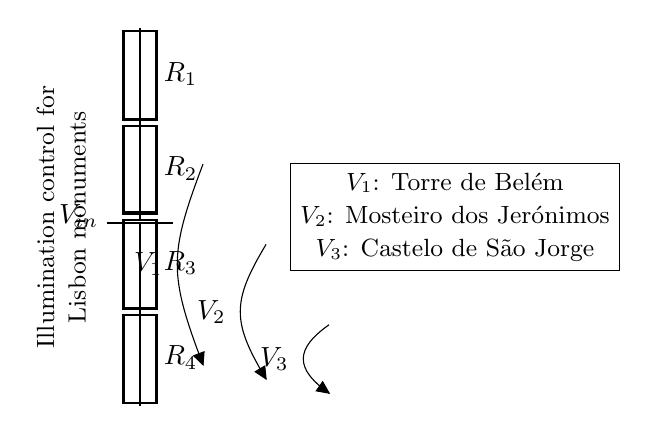What is the value of the input voltage? The input voltage is labeled as V_in at the top of the circuit, indicating the source of electrical power for the voltage divider.
Answer: V_in What components are present in this circuit? The circuit consists of a battery and four resistors labeled R_1, R_2, R_3, and R_4, which are connected in series.
Answer: Battery and four resistors How many output voltages are there in total? The circuit shows three output voltages labeled as V_1, V_2, and V_3, corresponding to different points in the voltage divider.
Answer: Three Which monument is associated with the voltage V_1? The voltage V_1 is specified in the circuit diagram to correspond to Torre de Belém, a historic monument in Lisbon.
Answer: Torre de Belém How do the voltage outputs relate to the resistors? The voltage outputs V_1, V_2, and V_3 are derived from the voltage division across the resistors R_1, R_2, and R_3, following the voltage divider rule. The relationship is determined by the values of the resistors and their series configuration.
Answer: By voltage division What is the role of the resistors in this circuit? The resistors in the circuit serve to divide the input voltage into several lower voltages, allowing for controlled illumination of the monuments based on the set voltage levels at the outputs.
Answer: Voltage division 